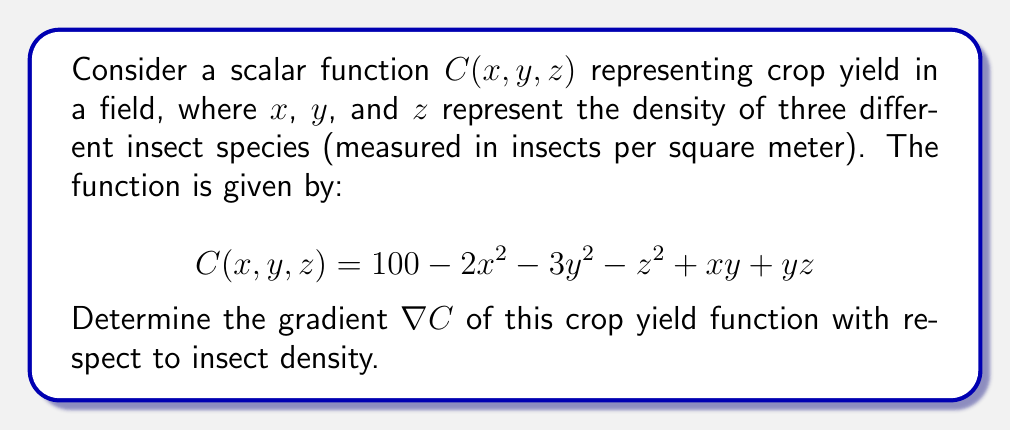Teach me how to tackle this problem. To find the gradient of the scalar function $C(x, y, z)$, we need to calculate the partial derivatives with respect to each variable:

1. Calculate $\frac{\partial C}{\partial x}$:
   $$\frac{\partial C}{\partial x} = -4x + y$$

2. Calculate $\frac{\partial C}{\partial y}$:
   $$\frac{\partial C}{\partial y} = -6y + x + z$$

3. Calculate $\frac{\partial C}{\partial z}$:
   $$\frac{\partial C}{\partial z} = -2z + y$$

4. Combine the partial derivatives to form the gradient vector:
   $$\nabla C = \left(\frac{\partial C}{\partial x}, \frac{\partial C}{\partial y}, \frac{\partial C}{\partial z}\right)$$

5. Substitute the calculated partial derivatives:
   $$\nabla C = (-4x + y, -6y + x + z, -2z + y)$$

This gradient vector represents the direction of steepest increase in crop yield with respect to changes in insect density for each species.
Answer: $\nabla C = (-4x + y, -6y + x + z, -2z + y)$ 